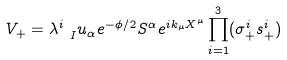Convert formula to latex. <formula><loc_0><loc_0><loc_500><loc_500>V _ { + } = \lambda ^ { i } _ { \ I } u _ { \alpha } e ^ { - \phi / 2 } S ^ { \alpha } e ^ { i k _ { \mu } X ^ { \mu } } \prod _ { i = 1 } ^ { 3 } ( \sigma _ { + } ^ { i } s _ { + } ^ { i } )</formula> 